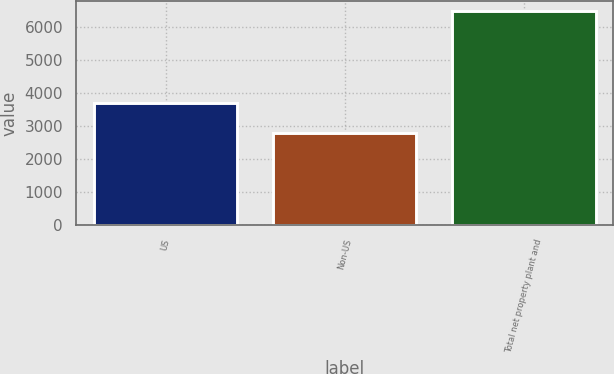<chart> <loc_0><loc_0><loc_500><loc_500><bar_chart><fcel>US<fcel>Non-US<fcel>Total net property plant and<nl><fcel>3693<fcel>2789<fcel>6482<nl></chart> 